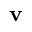Convert formula to latex. <formula><loc_0><loc_0><loc_500><loc_500>v</formula> 